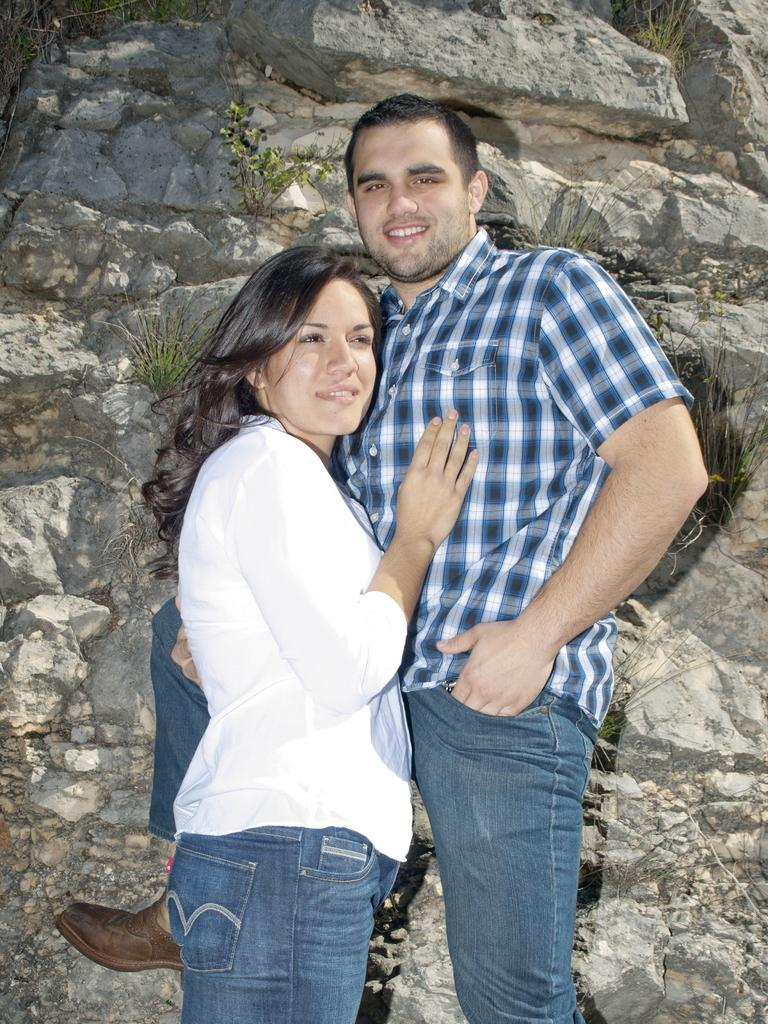Who are the people in the image? There is a lady and a guy in the image. What are the lady and the guy doing in the image? Both the lady and the guy are standing. What can be seen in the background of the image? There are rocks visible in the background of the image. What type of fang can be seen in the image? There is no fang present in the image. How many needles are visible in the image? There are no needles visible in the image. 